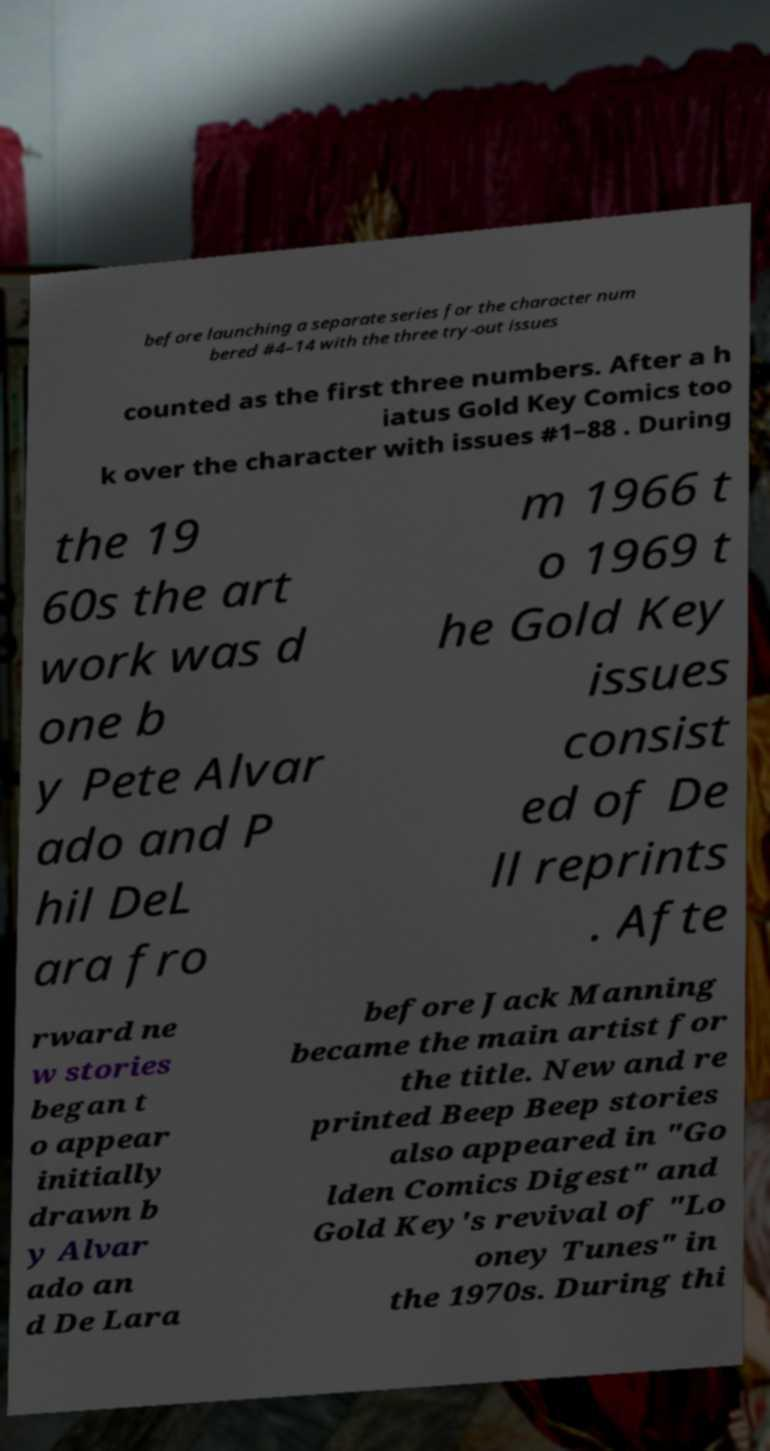Can you read and provide the text displayed in the image?This photo seems to have some interesting text. Can you extract and type it out for me? before launching a separate series for the character num bered #4–14 with the three try-out issues counted as the first three numbers. After a h iatus Gold Key Comics too k over the character with issues #1–88 . During the 19 60s the art work was d one b y Pete Alvar ado and P hil DeL ara fro m 1966 t o 1969 t he Gold Key issues consist ed of De ll reprints . Afte rward ne w stories began t o appear initially drawn b y Alvar ado an d De Lara before Jack Manning became the main artist for the title. New and re printed Beep Beep stories also appeared in "Go lden Comics Digest" and Gold Key's revival of "Lo oney Tunes" in the 1970s. During thi 